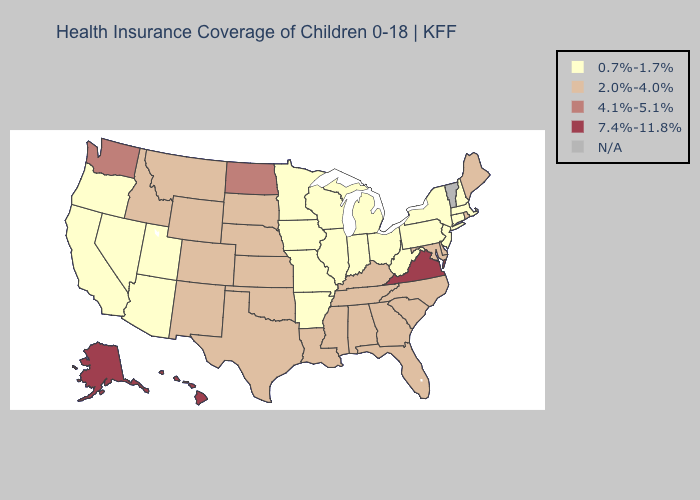What is the lowest value in states that border Georgia?
Write a very short answer. 2.0%-4.0%. Which states have the lowest value in the USA?
Keep it brief. Arizona, Arkansas, California, Connecticut, Illinois, Indiana, Iowa, Massachusetts, Michigan, Minnesota, Missouri, Nevada, New Hampshire, New Jersey, New York, Ohio, Oregon, Pennsylvania, Utah, West Virginia, Wisconsin. Does the first symbol in the legend represent the smallest category?
Quick response, please. Yes. What is the value of Georgia?
Answer briefly. 2.0%-4.0%. Does the map have missing data?
Short answer required. Yes. Name the states that have a value in the range 4.1%-5.1%?
Quick response, please. North Dakota, Washington. Name the states that have a value in the range N/A?
Quick response, please. Vermont. What is the highest value in the West ?
Answer briefly. 7.4%-11.8%. What is the value of Maine?
Keep it brief. 2.0%-4.0%. What is the highest value in the South ?
Quick response, please. 7.4%-11.8%. How many symbols are there in the legend?
Short answer required. 5. What is the value of South Carolina?
Concise answer only. 2.0%-4.0%. What is the highest value in states that border Maryland?
Answer briefly. 7.4%-11.8%. 